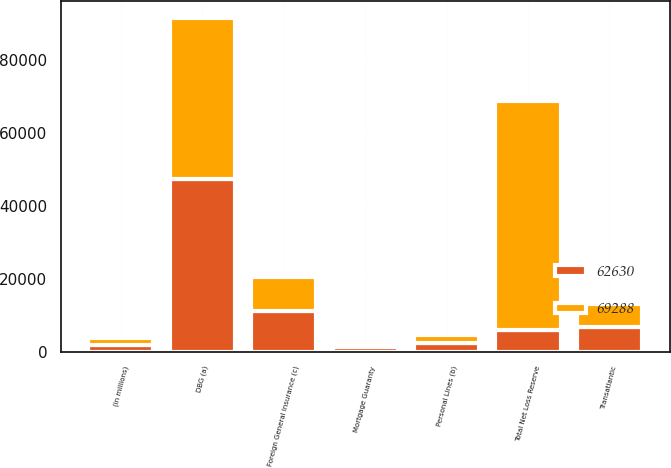Convert chart to OTSL. <chart><loc_0><loc_0><loc_500><loc_500><stacked_bar_chart><ecel><fcel>(in millions)<fcel>DBG (a)<fcel>Transatlantic<fcel>Personal Lines (b)<fcel>Mortgage Guaranty<fcel>Foreign General Insurance (c)<fcel>Total Net Loss Reserve<nl><fcel>62630<fcel>2007<fcel>47392<fcel>6900<fcel>2417<fcel>1339<fcel>11240<fcel>6207<nl><fcel>69288<fcel>2006<fcel>44119<fcel>6207<fcel>2440<fcel>460<fcel>9404<fcel>62630<nl></chart> 